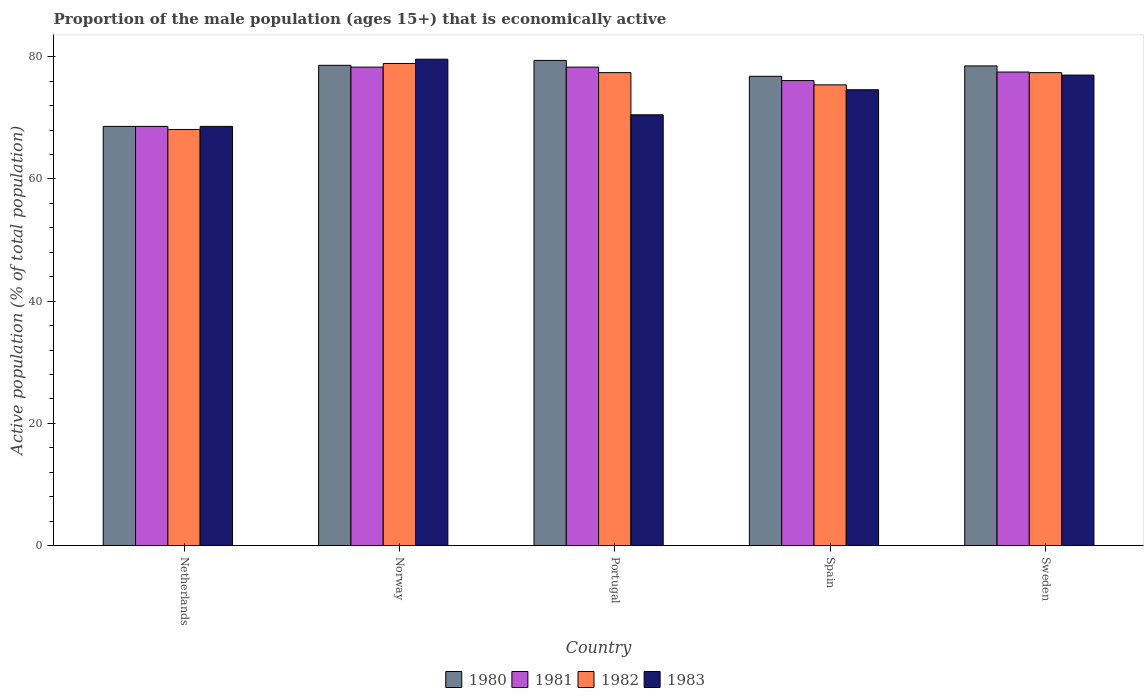How many groups of bars are there?
Keep it short and to the point. 5. Are the number of bars per tick equal to the number of legend labels?
Your answer should be compact. Yes. How many bars are there on the 1st tick from the left?
Ensure brevity in your answer.  4. What is the proportion of the male population that is economically active in 1983 in Netherlands?
Make the answer very short. 68.6. Across all countries, what is the maximum proportion of the male population that is economically active in 1981?
Give a very brief answer. 78.3. Across all countries, what is the minimum proportion of the male population that is economically active in 1982?
Give a very brief answer. 68.1. In which country was the proportion of the male population that is economically active in 1980 minimum?
Your answer should be very brief. Netherlands. What is the total proportion of the male population that is economically active in 1983 in the graph?
Offer a very short reply. 370.3. What is the difference between the proportion of the male population that is economically active in 1982 in Norway and the proportion of the male population that is economically active in 1981 in Portugal?
Make the answer very short. 0.6. What is the average proportion of the male population that is economically active in 1983 per country?
Your response must be concise. 74.06. What is the difference between the proportion of the male population that is economically active of/in 1982 and proportion of the male population that is economically active of/in 1983 in Spain?
Your response must be concise. 0.8. What is the ratio of the proportion of the male population that is economically active in 1983 in Netherlands to that in Norway?
Your answer should be very brief. 0.86. Is the difference between the proportion of the male population that is economically active in 1982 in Norway and Spain greater than the difference between the proportion of the male population that is economically active in 1983 in Norway and Spain?
Offer a very short reply. No. What is the difference between the highest and the second highest proportion of the male population that is economically active in 1980?
Your response must be concise. -0.1. What is the difference between the highest and the lowest proportion of the male population that is economically active in 1981?
Your answer should be very brief. 9.7. Is the sum of the proportion of the male population that is economically active in 1982 in Netherlands and Sweden greater than the maximum proportion of the male population that is economically active in 1980 across all countries?
Your answer should be very brief. Yes. Is it the case that in every country, the sum of the proportion of the male population that is economically active in 1980 and proportion of the male population that is economically active in 1981 is greater than the sum of proportion of the male population that is economically active in 1983 and proportion of the male population that is economically active in 1982?
Offer a terse response. No. What does the 3rd bar from the right in Sweden represents?
Your answer should be compact. 1981. How many bars are there?
Offer a terse response. 20. Are all the bars in the graph horizontal?
Provide a succinct answer. No. How many countries are there in the graph?
Offer a very short reply. 5. Does the graph contain grids?
Offer a very short reply. No. How are the legend labels stacked?
Provide a succinct answer. Horizontal. What is the title of the graph?
Offer a terse response. Proportion of the male population (ages 15+) that is economically active. Does "1981" appear as one of the legend labels in the graph?
Provide a short and direct response. Yes. What is the label or title of the X-axis?
Ensure brevity in your answer.  Country. What is the label or title of the Y-axis?
Make the answer very short. Active population (% of total population). What is the Active population (% of total population) of 1980 in Netherlands?
Ensure brevity in your answer.  68.6. What is the Active population (% of total population) of 1981 in Netherlands?
Provide a succinct answer. 68.6. What is the Active population (% of total population) in 1982 in Netherlands?
Provide a succinct answer. 68.1. What is the Active population (% of total population) in 1983 in Netherlands?
Provide a short and direct response. 68.6. What is the Active population (% of total population) of 1980 in Norway?
Ensure brevity in your answer.  78.6. What is the Active population (% of total population) of 1981 in Norway?
Offer a terse response. 78.3. What is the Active population (% of total population) in 1982 in Norway?
Make the answer very short. 78.9. What is the Active population (% of total population) of 1983 in Norway?
Provide a short and direct response. 79.6. What is the Active population (% of total population) of 1980 in Portugal?
Your answer should be very brief. 79.4. What is the Active population (% of total population) of 1981 in Portugal?
Give a very brief answer. 78.3. What is the Active population (% of total population) of 1982 in Portugal?
Offer a very short reply. 77.4. What is the Active population (% of total population) in 1983 in Portugal?
Your answer should be compact. 70.5. What is the Active population (% of total population) of 1980 in Spain?
Give a very brief answer. 76.8. What is the Active population (% of total population) in 1981 in Spain?
Ensure brevity in your answer.  76.1. What is the Active population (% of total population) of 1982 in Spain?
Your answer should be compact. 75.4. What is the Active population (% of total population) of 1983 in Spain?
Offer a terse response. 74.6. What is the Active population (% of total population) of 1980 in Sweden?
Offer a very short reply. 78.5. What is the Active population (% of total population) of 1981 in Sweden?
Offer a very short reply. 77.5. What is the Active population (% of total population) of 1982 in Sweden?
Your answer should be compact. 77.4. Across all countries, what is the maximum Active population (% of total population) in 1980?
Your answer should be very brief. 79.4. Across all countries, what is the maximum Active population (% of total population) in 1981?
Provide a short and direct response. 78.3. Across all countries, what is the maximum Active population (% of total population) of 1982?
Provide a succinct answer. 78.9. Across all countries, what is the maximum Active population (% of total population) of 1983?
Provide a succinct answer. 79.6. Across all countries, what is the minimum Active population (% of total population) of 1980?
Ensure brevity in your answer.  68.6. Across all countries, what is the minimum Active population (% of total population) in 1981?
Give a very brief answer. 68.6. Across all countries, what is the minimum Active population (% of total population) in 1982?
Your answer should be very brief. 68.1. Across all countries, what is the minimum Active population (% of total population) of 1983?
Offer a terse response. 68.6. What is the total Active population (% of total population) of 1980 in the graph?
Offer a terse response. 381.9. What is the total Active population (% of total population) of 1981 in the graph?
Keep it short and to the point. 378.8. What is the total Active population (% of total population) in 1982 in the graph?
Provide a short and direct response. 377.2. What is the total Active population (% of total population) of 1983 in the graph?
Your answer should be compact. 370.3. What is the difference between the Active population (% of total population) in 1980 in Netherlands and that in Norway?
Offer a terse response. -10. What is the difference between the Active population (% of total population) in 1980 in Netherlands and that in Portugal?
Keep it short and to the point. -10.8. What is the difference between the Active population (% of total population) of 1981 in Netherlands and that in Portugal?
Your answer should be compact. -9.7. What is the difference between the Active population (% of total population) of 1980 in Netherlands and that in Sweden?
Provide a succinct answer. -9.9. What is the difference between the Active population (% of total population) in 1980 in Norway and that in Portugal?
Provide a succinct answer. -0.8. What is the difference between the Active population (% of total population) of 1981 in Norway and that in Portugal?
Offer a terse response. 0. What is the difference between the Active population (% of total population) in 1983 in Norway and that in Portugal?
Provide a succinct answer. 9.1. What is the difference between the Active population (% of total population) of 1981 in Norway and that in Spain?
Provide a short and direct response. 2.2. What is the difference between the Active population (% of total population) in 1982 in Norway and that in Spain?
Provide a short and direct response. 3.5. What is the difference between the Active population (% of total population) in 1983 in Norway and that in Spain?
Make the answer very short. 5. What is the difference between the Active population (% of total population) in 1980 in Norway and that in Sweden?
Your response must be concise. 0.1. What is the difference between the Active population (% of total population) in 1981 in Norway and that in Sweden?
Ensure brevity in your answer.  0.8. What is the difference between the Active population (% of total population) in 1980 in Portugal and that in Spain?
Give a very brief answer. 2.6. What is the difference between the Active population (% of total population) in 1983 in Portugal and that in Spain?
Offer a terse response. -4.1. What is the difference between the Active population (% of total population) in 1980 in Portugal and that in Sweden?
Your answer should be compact. 0.9. What is the difference between the Active population (% of total population) in 1981 in Portugal and that in Sweden?
Give a very brief answer. 0.8. What is the difference between the Active population (% of total population) of 1983 in Portugal and that in Sweden?
Offer a very short reply. -6.5. What is the difference between the Active population (% of total population) of 1981 in Spain and that in Sweden?
Your answer should be very brief. -1.4. What is the difference between the Active population (% of total population) of 1980 in Netherlands and the Active population (% of total population) of 1982 in Norway?
Give a very brief answer. -10.3. What is the difference between the Active population (% of total population) of 1980 in Netherlands and the Active population (% of total population) of 1983 in Norway?
Your response must be concise. -11. What is the difference between the Active population (% of total population) of 1981 in Netherlands and the Active population (% of total population) of 1983 in Norway?
Provide a short and direct response. -11. What is the difference between the Active population (% of total population) in 1980 in Netherlands and the Active population (% of total population) in 1982 in Portugal?
Offer a very short reply. -8.8. What is the difference between the Active population (% of total population) of 1980 in Netherlands and the Active population (% of total population) of 1983 in Portugal?
Give a very brief answer. -1.9. What is the difference between the Active population (% of total population) of 1981 in Netherlands and the Active population (% of total population) of 1982 in Portugal?
Provide a short and direct response. -8.8. What is the difference between the Active population (% of total population) of 1982 in Netherlands and the Active population (% of total population) of 1983 in Portugal?
Your response must be concise. -2.4. What is the difference between the Active population (% of total population) in 1980 in Netherlands and the Active population (% of total population) in 1982 in Spain?
Offer a terse response. -6.8. What is the difference between the Active population (% of total population) of 1980 in Netherlands and the Active population (% of total population) of 1983 in Spain?
Your answer should be very brief. -6. What is the difference between the Active population (% of total population) in 1982 in Netherlands and the Active population (% of total population) in 1983 in Spain?
Make the answer very short. -6.5. What is the difference between the Active population (% of total population) in 1980 in Netherlands and the Active population (% of total population) in 1981 in Sweden?
Make the answer very short. -8.9. What is the difference between the Active population (% of total population) in 1980 in Netherlands and the Active population (% of total population) in 1983 in Sweden?
Make the answer very short. -8.4. What is the difference between the Active population (% of total population) of 1981 in Netherlands and the Active population (% of total population) of 1983 in Sweden?
Offer a terse response. -8.4. What is the difference between the Active population (% of total population) in 1981 in Norway and the Active population (% of total population) in 1983 in Portugal?
Provide a short and direct response. 7.8. What is the difference between the Active population (% of total population) of 1981 in Norway and the Active population (% of total population) of 1983 in Spain?
Provide a succinct answer. 3.7. What is the difference between the Active population (% of total population) in 1980 in Norway and the Active population (% of total population) in 1982 in Sweden?
Your answer should be very brief. 1.2. What is the difference between the Active population (% of total population) in 1980 in Norway and the Active population (% of total population) in 1983 in Sweden?
Keep it short and to the point. 1.6. What is the difference between the Active population (% of total population) of 1981 in Norway and the Active population (% of total population) of 1983 in Sweden?
Provide a short and direct response. 1.3. What is the difference between the Active population (% of total population) in 1982 in Norway and the Active population (% of total population) in 1983 in Sweden?
Offer a very short reply. 1.9. What is the difference between the Active population (% of total population) of 1980 in Portugal and the Active population (% of total population) of 1983 in Spain?
Make the answer very short. 4.8. What is the difference between the Active population (% of total population) of 1981 in Portugal and the Active population (% of total population) of 1983 in Spain?
Offer a very short reply. 3.7. What is the difference between the Active population (% of total population) of 1980 in Portugal and the Active population (% of total population) of 1981 in Sweden?
Offer a terse response. 1.9. What is the difference between the Active population (% of total population) in 1980 in Portugal and the Active population (% of total population) in 1982 in Sweden?
Provide a short and direct response. 2. What is the difference between the Active population (% of total population) in 1981 in Portugal and the Active population (% of total population) in 1983 in Sweden?
Your answer should be very brief. 1.3. What is the difference between the Active population (% of total population) in 1982 in Portugal and the Active population (% of total population) in 1983 in Sweden?
Provide a short and direct response. 0.4. What is the difference between the Active population (% of total population) in 1980 in Spain and the Active population (% of total population) in 1982 in Sweden?
Provide a short and direct response. -0.6. What is the difference between the Active population (% of total population) of 1980 in Spain and the Active population (% of total population) of 1983 in Sweden?
Provide a succinct answer. -0.2. What is the difference between the Active population (% of total population) of 1981 in Spain and the Active population (% of total population) of 1982 in Sweden?
Your answer should be compact. -1.3. What is the average Active population (% of total population) of 1980 per country?
Provide a short and direct response. 76.38. What is the average Active population (% of total population) in 1981 per country?
Make the answer very short. 75.76. What is the average Active population (% of total population) in 1982 per country?
Offer a very short reply. 75.44. What is the average Active population (% of total population) in 1983 per country?
Provide a succinct answer. 74.06. What is the difference between the Active population (% of total population) in 1980 and Active population (% of total population) in 1981 in Netherlands?
Provide a short and direct response. 0. What is the difference between the Active population (% of total population) in 1981 and Active population (% of total population) in 1982 in Netherlands?
Your answer should be compact. 0.5. What is the difference between the Active population (% of total population) of 1981 and Active population (% of total population) of 1983 in Netherlands?
Make the answer very short. 0. What is the difference between the Active population (% of total population) of 1980 and Active population (% of total population) of 1981 in Norway?
Keep it short and to the point. 0.3. What is the difference between the Active population (% of total population) of 1981 and Active population (% of total population) of 1982 in Norway?
Ensure brevity in your answer.  -0.6. What is the difference between the Active population (% of total population) in 1981 and Active population (% of total population) in 1983 in Norway?
Your answer should be very brief. -1.3. What is the difference between the Active population (% of total population) in 1982 and Active population (% of total population) in 1983 in Norway?
Keep it short and to the point. -0.7. What is the difference between the Active population (% of total population) of 1980 and Active population (% of total population) of 1981 in Portugal?
Offer a terse response. 1.1. What is the difference between the Active population (% of total population) of 1980 and Active population (% of total population) of 1982 in Portugal?
Give a very brief answer. 2. What is the difference between the Active population (% of total population) of 1980 and Active population (% of total population) of 1983 in Portugal?
Offer a terse response. 8.9. What is the difference between the Active population (% of total population) of 1981 and Active population (% of total population) of 1982 in Portugal?
Keep it short and to the point. 0.9. What is the difference between the Active population (% of total population) in 1981 and Active population (% of total population) in 1983 in Portugal?
Give a very brief answer. 7.8. What is the difference between the Active population (% of total population) in 1982 and Active population (% of total population) in 1983 in Portugal?
Make the answer very short. 6.9. What is the difference between the Active population (% of total population) of 1980 and Active population (% of total population) of 1982 in Spain?
Provide a short and direct response. 1.4. What is the difference between the Active population (% of total population) in 1980 and Active population (% of total population) in 1983 in Spain?
Ensure brevity in your answer.  2.2. What is the difference between the Active population (% of total population) of 1981 and Active population (% of total population) of 1982 in Spain?
Give a very brief answer. 0.7. What is the difference between the Active population (% of total population) of 1981 and Active population (% of total population) of 1983 in Spain?
Your answer should be very brief. 1.5. What is the difference between the Active population (% of total population) of 1982 and Active population (% of total population) of 1983 in Spain?
Provide a short and direct response. 0.8. What is the difference between the Active population (% of total population) in 1980 and Active population (% of total population) in 1981 in Sweden?
Your answer should be compact. 1. What is the difference between the Active population (% of total population) in 1980 and Active population (% of total population) in 1983 in Sweden?
Ensure brevity in your answer.  1.5. What is the difference between the Active population (% of total population) in 1982 and Active population (% of total population) in 1983 in Sweden?
Offer a very short reply. 0.4. What is the ratio of the Active population (% of total population) of 1980 in Netherlands to that in Norway?
Your answer should be compact. 0.87. What is the ratio of the Active population (% of total population) of 1981 in Netherlands to that in Norway?
Your answer should be compact. 0.88. What is the ratio of the Active population (% of total population) of 1982 in Netherlands to that in Norway?
Offer a terse response. 0.86. What is the ratio of the Active population (% of total population) in 1983 in Netherlands to that in Norway?
Your answer should be very brief. 0.86. What is the ratio of the Active population (% of total population) in 1980 in Netherlands to that in Portugal?
Give a very brief answer. 0.86. What is the ratio of the Active population (% of total population) in 1981 in Netherlands to that in Portugal?
Provide a succinct answer. 0.88. What is the ratio of the Active population (% of total population) in 1982 in Netherlands to that in Portugal?
Your answer should be very brief. 0.88. What is the ratio of the Active population (% of total population) of 1983 in Netherlands to that in Portugal?
Offer a very short reply. 0.97. What is the ratio of the Active population (% of total population) of 1980 in Netherlands to that in Spain?
Your answer should be compact. 0.89. What is the ratio of the Active population (% of total population) of 1981 in Netherlands to that in Spain?
Keep it short and to the point. 0.9. What is the ratio of the Active population (% of total population) in 1982 in Netherlands to that in Spain?
Offer a very short reply. 0.9. What is the ratio of the Active population (% of total population) in 1983 in Netherlands to that in Spain?
Offer a terse response. 0.92. What is the ratio of the Active population (% of total population) of 1980 in Netherlands to that in Sweden?
Your answer should be compact. 0.87. What is the ratio of the Active population (% of total population) in 1981 in Netherlands to that in Sweden?
Give a very brief answer. 0.89. What is the ratio of the Active population (% of total population) in 1982 in Netherlands to that in Sweden?
Keep it short and to the point. 0.88. What is the ratio of the Active population (% of total population) in 1983 in Netherlands to that in Sweden?
Offer a terse response. 0.89. What is the ratio of the Active population (% of total population) of 1980 in Norway to that in Portugal?
Give a very brief answer. 0.99. What is the ratio of the Active population (% of total population) of 1981 in Norway to that in Portugal?
Keep it short and to the point. 1. What is the ratio of the Active population (% of total population) of 1982 in Norway to that in Portugal?
Give a very brief answer. 1.02. What is the ratio of the Active population (% of total population) of 1983 in Norway to that in Portugal?
Ensure brevity in your answer.  1.13. What is the ratio of the Active population (% of total population) in 1980 in Norway to that in Spain?
Provide a short and direct response. 1.02. What is the ratio of the Active population (% of total population) in 1981 in Norway to that in Spain?
Offer a terse response. 1.03. What is the ratio of the Active population (% of total population) of 1982 in Norway to that in Spain?
Ensure brevity in your answer.  1.05. What is the ratio of the Active population (% of total population) of 1983 in Norway to that in Spain?
Make the answer very short. 1.07. What is the ratio of the Active population (% of total population) of 1981 in Norway to that in Sweden?
Offer a very short reply. 1.01. What is the ratio of the Active population (% of total population) of 1982 in Norway to that in Sweden?
Your answer should be compact. 1.02. What is the ratio of the Active population (% of total population) in 1983 in Norway to that in Sweden?
Offer a terse response. 1.03. What is the ratio of the Active population (% of total population) of 1980 in Portugal to that in Spain?
Make the answer very short. 1.03. What is the ratio of the Active population (% of total population) in 1981 in Portugal to that in Spain?
Ensure brevity in your answer.  1.03. What is the ratio of the Active population (% of total population) of 1982 in Portugal to that in Spain?
Ensure brevity in your answer.  1.03. What is the ratio of the Active population (% of total population) of 1983 in Portugal to that in Spain?
Your answer should be compact. 0.94. What is the ratio of the Active population (% of total population) of 1980 in Portugal to that in Sweden?
Ensure brevity in your answer.  1.01. What is the ratio of the Active population (% of total population) of 1981 in Portugal to that in Sweden?
Offer a terse response. 1.01. What is the ratio of the Active population (% of total population) in 1982 in Portugal to that in Sweden?
Your answer should be very brief. 1. What is the ratio of the Active population (% of total population) in 1983 in Portugal to that in Sweden?
Provide a succinct answer. 0.92. What is the ratio of the Active population (% of total population) in 1980 in Spain to that in Sweden?
Your answer should be very brief. 0.98. What is the ratio of the Active population (% of total population) in 1981 in Spain to that in Sweden?
Your answer should be compact. 0.98. What is the ratio of the Active population (% of total population) of 1982 in Spain to that in Sweden?
Provide a short and direct response. 0.97. What is the ratio of the Active population (% of total population) in 1983 in Spain to that in Sweden?
Your answer should be very brief. 0.97. What is the difference between the highest and the second highest Active population (% of total population) of 1982?
Your answer should be compact. 1.5. What is the difference between the highest and the lowest Active population (% of total population) of 1982?
Your answer should be very brief. 10.8. What is the difference between the highest and the lowest Active population (% of total population) of 1983?
Provide a succinct answer. 11. 